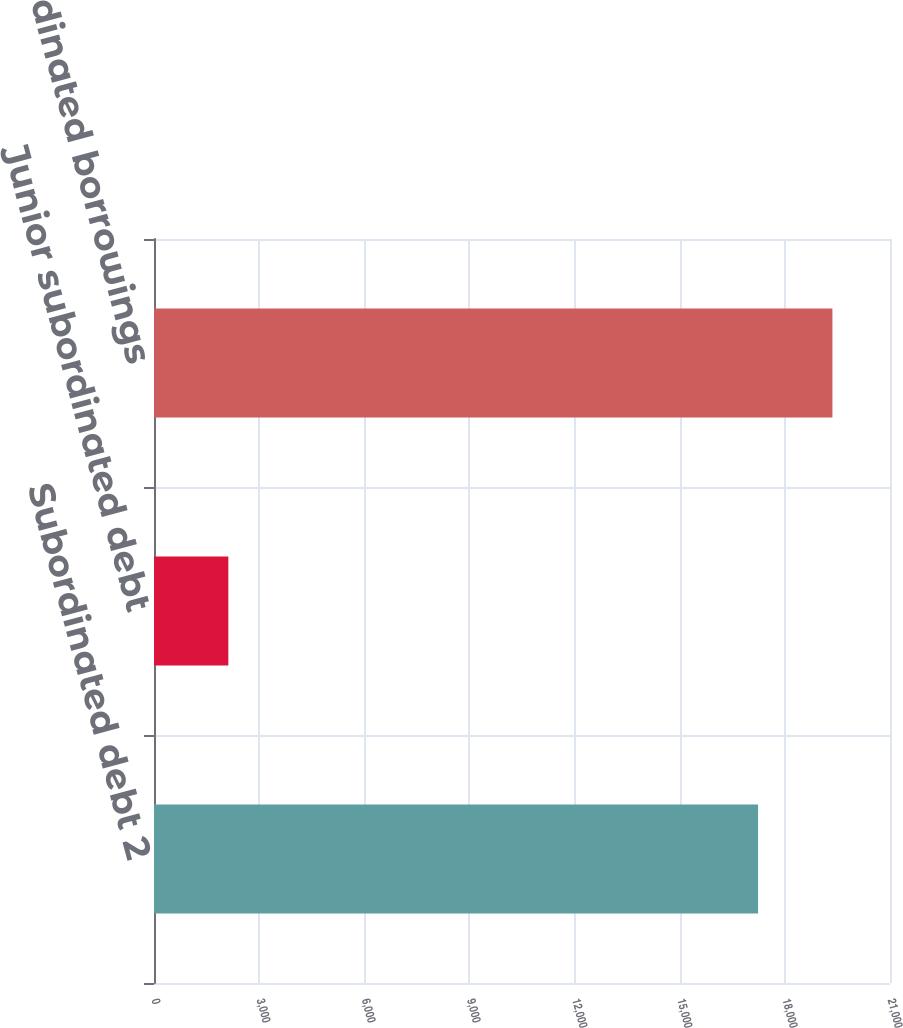Convert chart to OTSL. <chart><loc_0><loc_0><loc_500><loc_500><bar_chart><fcel>Subordinated debt 2<fcel>Junior subordinated debt<fcel>Total subordinated borrowings<nl><fcel>17236<fcel>2121<fcel>19357<nl></chart> 